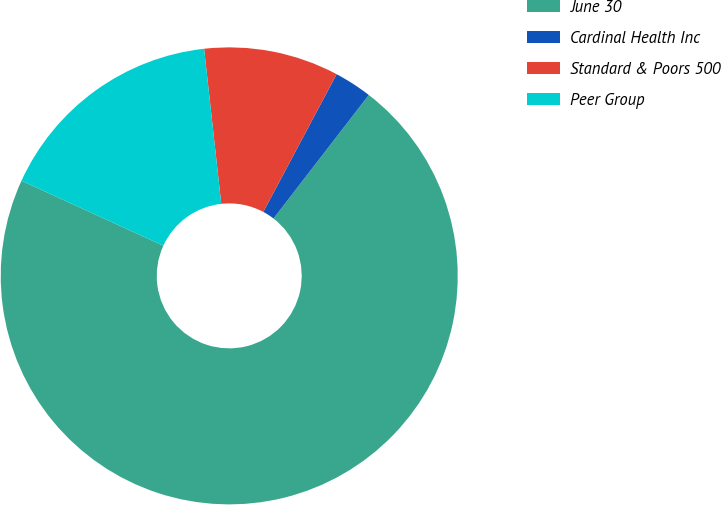Convert chart. <chart><loc_0><loc_0><loc_500><loc_500><pie_chart><fcel>June 30<fcel>Cardinal Health Inc<fcel>Standard & Poors 500<fcel>Peer Group<nl><fcel>71.37%<fcel>2.67%<fcel>9.54%<fcel>16.41%<nl></chart> 